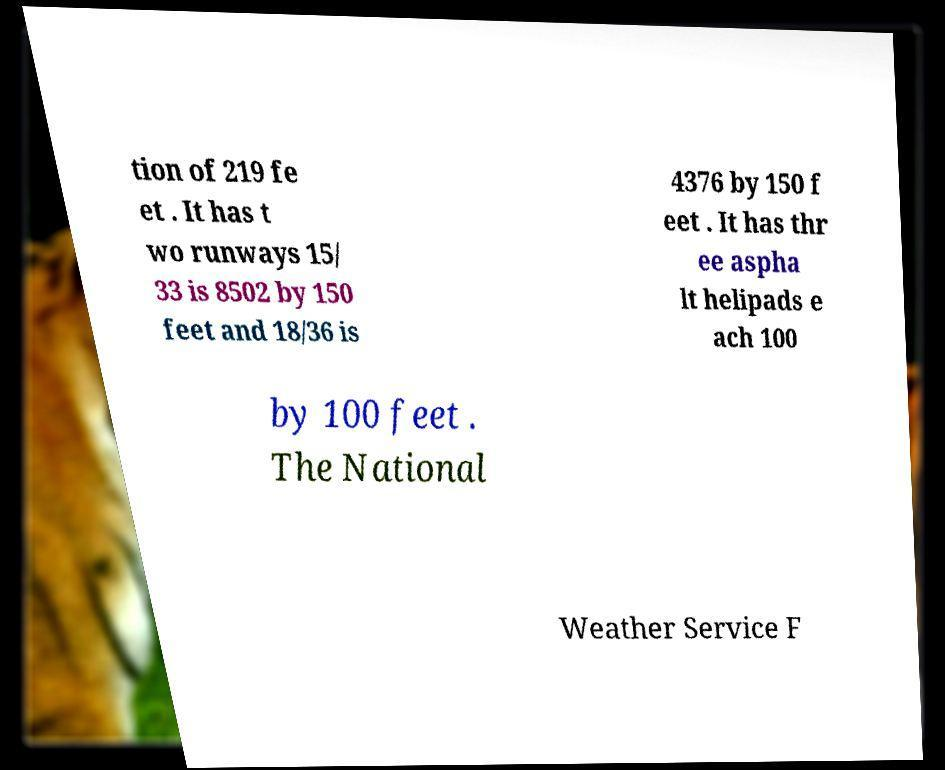I need the written content from this picture converted into text. Can you do that? tion of 219 fe et . It has t wo runways 15/ 33 is 8502 by 150 feet and 18/36 is 4376 by 150 f eet . It has thr ee aspha lt helipads e ach 100 by 100 feet . The National Weather Service F 